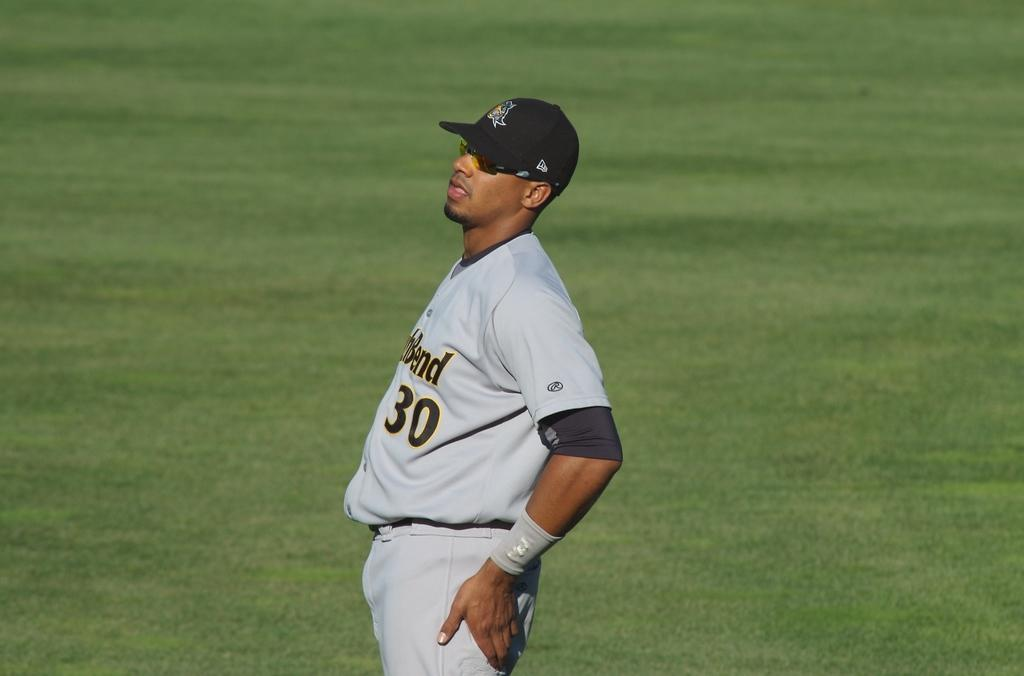Provide a one-sentence caption for the provided image. A baseball player with the partial word Bend on his jersey. 